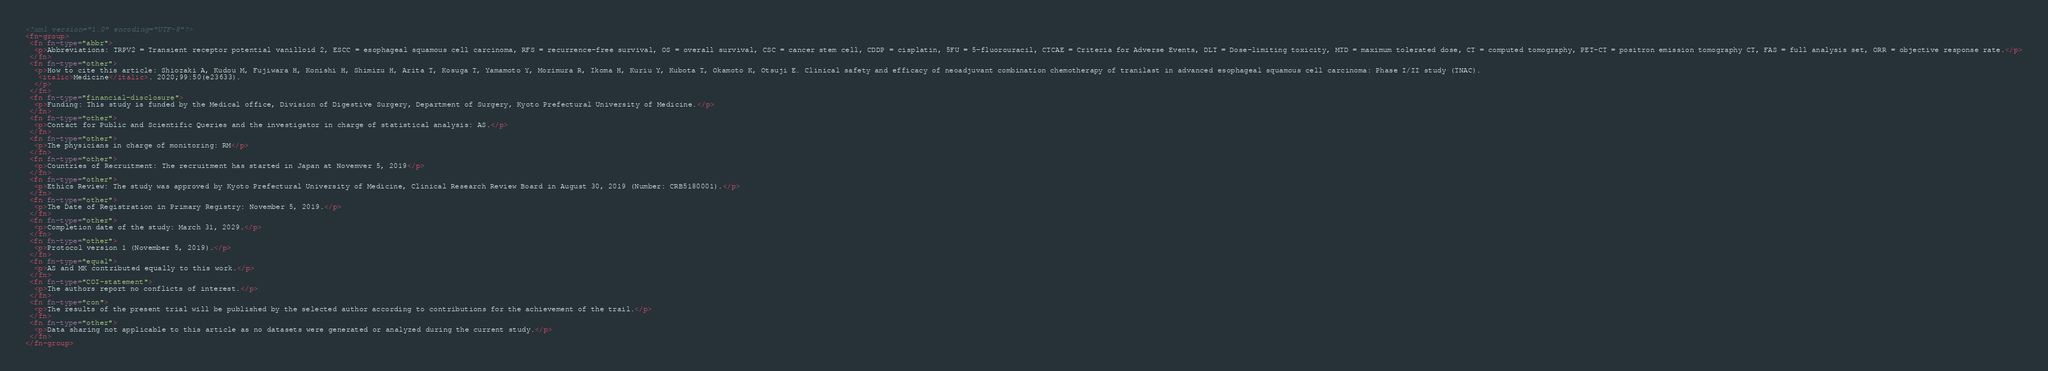Convert code to text. <code><loc_0><loc_0><loc_500><loc_500><_XML_><?xml version="1.0" encoding="UTF-8"?>
<fn-group>
 <fn fn-type="abbr">
  <p>Abbreviations: TRPV2 = Transient receptor potential vanilloid 2, ESCC = esophageal squamous cell carcinoma, RFS = recurrence-free survival, OS = overall survival, CSC = cancer stem cell, CDDP = cisplatin, 5FU = 5-fluorouracil, CTCAE = Criteria for Adverse Events, DLT = Dose-limiting toxicity, MTD = maximum tolerated dose, CT = computed tomography, PET-CT = positron emission tomography CT, FAS = full analysis set, ORR = objective response rate.</p>
 </fn>
 <fn fn-type="other">
  <p>How to cite this article: Shiozaki A, Kudou M, Fujiwara H, Konishi H, Shimizu H, Arita T, Kosuga T, Yamamoto Y, Morimura R, Ikoma H, Kuriu Y, Kubota T, Okamoto K, Otsuji E. Clinical safety and efficacy of neoadjuvant combination chemotherapy of tranilast in advanced esophageal squamous cell carcinoma: Phase I/II study (TNAC). 
   <italic>Medicine</italic>. 2020;99:50(e23633).
  </p>
 </fn>
 <fn fn-type="financial-disclosure">
  <p>Funding: This study is funded by the Medical office, Division of Digestive Surgery, Department of Surgery, Kyoto Prefectural University of Medicine.</p>
 </fn>
 <fn fn-type="other">
  <p>Contact for Public and Scientific Queries and the investigator in charge of statistical analysis: AS.</p>
 </fn>
 <fn fn-type="other">
  <p>The physicians in charge of monitoring: RM</p>
 </fn>
 <fn fn-type="other">
  <p>Countries of Recruitment: The recruitment has started in Japan at Novemver 5, 2019</p>
 </fn>
 <fn fn-type="other">
  <p>Ethics Review: The study was approved by Kyoto Prefectural University of Medicine, Clinical Research Review Board in August 30, 2019 (Number: CRB5180001).</p>
 </fn>
 <fn fn-type="other">
  <p>The Date of Registration in Primary Registry: November 5, 2019.</p>
 </fn>
 <fn fn-type="other">
  <p>Completion date of the study: March 31, 2029.</p>
 </fn>
 <fn fn-type="other">
  <p>Protocol version 1 (November 5, 2019).</p>
 </fn>
 <fn fn-type="equal">
  <p>AS and MK contributed equally to this work.</p>
 </fn>
 <fn fn-type="COI-statement">
  <p>The authors report no conflicts of interest.</p>
 </fn>
 <fn fn-type="con">
  <p>The results of the present trial will be published by the selected author according to contributions for the achievement of the trail.</p>
 </fn>
 <fn fn-type="other">
  <p>Data sharing not applicable to this article as no datasets were generated or analyzed during the current study.</p>
 </fn>
</fn-group>
</code> 